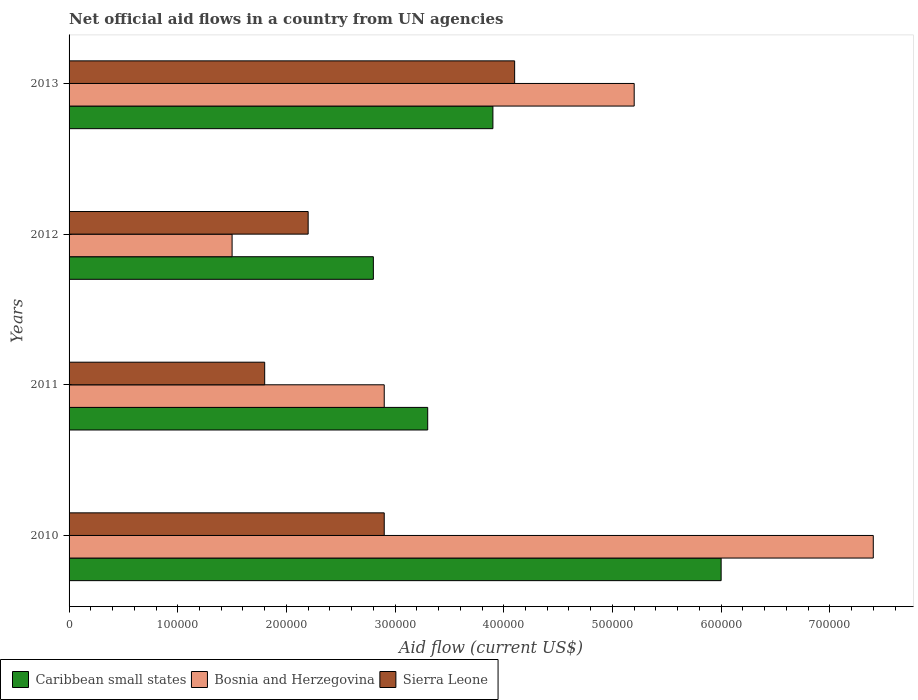How many groups of bars are there?
Offer a very short reply. 4. Are the number of bars per tick equal to the number of legend labels?
Keep it short and to the point. Yes. Are the number of bars on each tick of the Y-axis equal?
Keep it short and to the point. Yes. How many bars are there on the 4th tick from the bottom?
Ensure brevity in your answer.  3. What is the net official aid flow in Caribbean small states in 2010?
Your answer should be compact. 6.00e+05. Across all years, what is the maximum net official aid flow in Caribbean small states?
Provide a short and direct response. 6.00e+05. Across all years, what is the minimum net official aid flow in Bosnia and Herzegovina?
Keep it short and to the point. 1.50e+05. In which year was the net official aid flow in Bosnia and Herzegovina maximum?
Offer a terse response. 2010. In which year was the net official aid flow in Sierra Leone minimum?
Make the answer very short. 2011. What is the total net official aid flow in Bosnia and Herzegovina in the graph?
Your answer should be very brief. 1.70e+06. What is the difference between the net official aid flow in Sierra Leone in 2010 and that in 2013?
Ensure brevity in your answer.  -1.20e+05. What is the difference between the net official aid flow in Bosnia and Herzegovina in 2013 and the net official aid flow in Sierra Leone in 2012?
Ensure brevity in your answer.  3.00e+05. What is the average net official aid flow in Sierra Leone per year?
Offer a very short reply. 2.75e+05. In the year 2010, what is the difference between the net official aid flow in Caribbean small states and net official aid flow in Bosnia and Herzegovina?
Your response must be concise. -1.40e+05. What is the ratio of the net official aid flow in Bosnia and Herzegovina in 2011 to that in 2012?
Your answer should be very brief. 1.93. What is the difference between the highest and the lowest net official aid flow in Bosnia and Herzegovina?
Your response must be concise. 5.90e+05. In how many years, is the net official aid flow in Caribbean small states greater than the average net official aid flow in Caribbean small states taken over all years?
Give a very brief answer. 1. What does the 2nd bar from the top in 2010 represents?
Your response must be concise. Bosnia and Herzegovina. What does the 3rd bar from the bottom in 2012 represents?
Offer a very short reply. Sierra Leone. How many bars are there?
Ensure brevity in your answer.  12. What is the difference between two consecutive major ticks on the X-axis?
Provide a short and direct response. 1.00e+05. Where does the legend appear in the graph?
Provide a succinct answer. Bottom left. How are the legend labels stacked?
Your answer should be compact. Horizontal. What is the title of the graph?
Keep it short and to the point. Net official aid flows in a country from UN agencies. What is the Aid flow (current US$) in Bosnia and Herzegovina in 2010?
Offer a terse response. 7.40e+05. What is the Aid flow (current US$) of Caribbean small states in 2011?
Give a very brief answer. 3.30e+05. What is the Aid flow (current US$) of Caribbean small states in 2012?
Make the answer very short. 2.80e+05. What is the Aid flow (current US$) of Bosnia and Herzegovina in 2012?
Ensure brevity in your answer.  1.50e+05. What is the Aid flow (current US$) in Bosnia and Herzegovina in 2013?
Your answer should be compact. 5.20e+05. Across all years, what is the maximum Aid flow (current US$) in Caribbean small states?
Ensure brevity in your answer.  6.00e+05. Across all years, what is the maximum Aid flow (current US$) in Bosnia and Herzegovina?
Offer a terse response. 7.40e+05. Across all years, what is the minimum Aid flow (current US$) of Sierra Leone?
Provide a succinct answer. 1.80e+05. What is the total Aid flow (current US$) of Caribbean small states in the graph?
Give a very brief answer. 1.60e+06. What is the total Aid flow (current US$) in Bosnia and Herzegovina in the graph?
Ensure brevity in your answer.  1.70e+06. What is the total Aid flow (current US$) in Sierra Leone in the graph?
Offer a very short reply. 1.10e+06. What is the difference between the Aid flow (current US$) in Caribbean small states in 2010 and that in 2011?
Give a very brief answer. 2.70e+05. What is the difference between the Aid flow (current US$) in Caribbean small states in 2010 and that in 2012?
Your response must be concise. 3.20e+05. What is the difference between the Aid flow (current US$) in Bosnia and Herzegovina in 2010 and that in 2012?
Ensure brevity in your answer.  5.90e+05. What is the difference between the Aid flow (current US$) in Sierra Leone in 2010 and that in 2012?
Your answer should be compact. 7.00e+04. What is the difference between the Aid flow (current US$) of Bosnia and Herzegovina in 2010 and that in 2013?
Provide a short and direct response. 2.20e+05. What is the difference between the Aid flow (current US$) in Sierra Leone in 2010 and that in 2013?
Keep it short and to the point. -1.20e+05. What is the difference between the Aid flow (current US$) of Caribbean small states in 2011 and that in 2012?
Your answer should be very brief. 5.00e+04. What is the difference between the Aid flow (current US$) in Bosnia and Herzegovina in 2011 and that in 2012?
Provide a succinct answer. 1.40e+05. What is the difference between the Aid flow (current US$) in Sierra Leone in 2011 and that in 2012?
Make the answer very short. -4.00e+04. What is the difference between the Aid flow (current US$) of Caribbean small states in 2011 and that in 2013?
Give a very brief answer. -6.00e+04. What is the difference between the Aid flow (current US$) in Bosnia and Herzegovina in 2011 and that in 2013?
Keep it short and to the point. -2.30e+05. What is the difference between the Aid flow (current US$) of Bosnia and Herzegovina in 2012 and that in 2013?
Offer a terse response. -3.70e+05. What is the difference between the Aid flow (current US$) in Caribbean small states in 2010 and the Aid flow (current US$) in Bosnia and Herzegovina in 2011?
Ensure brevity in your answer.  3.10e+05. What is the difference between the Aid flow (current US$) in Bosnia and Herzegovina in 2010 and the Aid flow (current US$) in Sierra Leone in 2011?
Keep it short and to the point. 5.60e+05. What is the difference between the Aid flow (current US$) of Caribbean small states in 2010 and the Aid flow (current US$) of Bosnia and Herzegovina in 2012?
Your answer should be very brief. 4.50e+05. What is the difference between the Aid flow (current US$) in Bosnia and Herzegovina in 2010 and the Aid flow (current US$) in Sierra Leone in 2012?
Keep it short and to the point. 5.20e+05. What is the difference between the Aid flow (current US$) in Caribbean small states in 2010 and the Aid flow (current US$) in Sierra Leone in 2013?
Provide a succinct answer. 1.90e+05. What is the difference between the Aid flow (current US$) of Bosnia and Herzegovina in 2011 and the Aid flow (current US$) of Sierra Leone in 2012?
Keep it short and to the point. 7.00e+04. What is the difference between the Aid flow (current US$) of Caribbean small states in 2011 and the Aid flow (current US$) of Sierra Leone in 2013?
Your answer should be compact. -8.00e+04. What is the difference between the Aid flow (current US$) of Caribbean small states in 2012 and the Aid flow (current US$) of Bosnia and Herzegovina in 2013?
Keep it short and to the point. -2.40e+05. What is the average Aid flow (current US$) in Bosnia and Herzegovina per year?
Ensure brevity in your answer.  4.25e+05. What is the average Aid flow (current US$) in Sierra Leone per year?
Offer a terse response. 2.75e+05. In the year 2010, what is the difference between the Aid flow (current US$) of Caribbean small states and Aid flow (current US$) of Bosnia and Herzegovina?
Ensure brevity in your answer.  -1.40e+05. In the year 2010, what is the difference between the Aid flow (current US$) of Caribbean small states and Aid flow (current US$) of Sierra Leone?
Keep it short and to the point. 3.10e+05. In the year 2010, what is the difference between the Aid flow (current US$) in Bosnia and Herzegovina and Aid flow (current US$) in Sierra Leone?
Make the answer very short. 4.50e+05. In the year 2011, what is the difference between the Aid flow (current US$) of Caribbean small states and Aid flow (current US$) of Sierra Leone?
Offer a very short reply. 1.50e+05. In the year 2011, what is the difference between the Aid flow (current US$) in Bosnia and Herzegovina and Aid flow (current US$) in Sierra Leone?
Offer a very short reply. 1.10e+05. In the year 2012, what is the difference between the Aid flow (current US$) of Caribbean small states and Aid flow (current US$) of Sierra Leone?
Offer a very short reply. 6.00e+04. In the year 2013, what is the difference between the Aid flow (current US$) of Caribbean small states and Aid flow (current US$) of Bosnia and Herzegovina?
Ensure brevity in your answer.  -1.30e+05. In the year 2013, what is the difference between the Aid flow (current US$) of Bosnia and Herzegovina and Aid flow (current US$) of Sierra Leone?
Your answer should be compact. 1.10e+05. What is the ratio of the Aid flow (current US$) in Caribbean small states in 2010 to that in 2011?
Your response must be concise. 1.82. What is the ratio of the Aid flow (current US$) in Bosnia and Herzegovina in 2010 to that in 2011?
Ensure brevity in your answer.  2.55. What is the ratio of the Aid flow (current US$) of Sierra Leone in 2010 to that in 2011?
Make the answer very short. 1.61. What is the ratio of the Aid flow (current US$) in Caribbean small states in 2010 to that in 2012?
Provide a succinct answer. 2.14. What is the ratio of the Aid flow (current US$) in Bosnia and Herzegovina in 2010 to that in 2012?
Make the answer very short. 4.93. What is the ratio of the Aid flow (current US$) of Sierra Leone in 2010 to that in 2012?
Keep it short and to the point. 1.32. What is the ratio of the Aid flow (current US$) of Caribbean small states in 2010 to that in 2013?
Provide a succinct answer. 1.54. What is the ratio of the Aid flow (current US$) in Bosnia and Herzegovina in 2010 to that in 2013?
Make the answer very short. 1.42. What is the ratio of the Aid flow (current US$) in Sierra Leone in 2010 to that in 2013?
Offer a terse response. 0.71. What is the ratio of the Aid flow (current US$) in Caribbean small states in 2011 to that in 2012?
Make the answer very short. 1.18. What is the ratio of the Aid flow (current US$) of Bosnia and Herzegovina in 2011 to that in 2012?
Your answer should be very brief. 1.93. What is the ratio of the Aid flow (current US$) of Sierra Leone in 2011 to that in 2012?
Provide a short and direct response. 0.82. What is the ratio of the Aid flow (current US$) in Caribbean small states in 2011 to that in 2013?
Your answer should be very brief. 0.85. What is the ratio of the Aid flow (current US$) in Bosnia and Herzegovina in 2011 to that in 2013?
Your response must be concise. 0.56. What is the ratio of the Aid flow (current US$) in Sierra Leone in 2011 to that in 2013?
Your answer should be compact. 0.44. What is the ratio of the Aid flow (current US$) in Caribbean small states in 2012 to that in 2013?
Your answer should be compact. 0.72. What is the ratio of the Aid flow (current US$) in Bosnia and Herzegovina in 2012 to that in 2013?
Keep it short and to the point. 0.29. What is the ratio of the Aid flow (current US$) of Sierra Leone in 2012 to that in 2013?
Your answer should be compact. 0.54. What is the difference between the highest and the second highest Aid flow (current US$) in Bosnia and Herzegovina?
Your answer should be very brief. 2.20e+05. What is the difference between the highest and the second highest Aid flow (current US$) in Sierra Leone?
Your answer should be compact. 1.20e+05. What is the difference between the highest and the lowest Aid flow (current US$) of Caribbean small states?
Your answer should be compact. 3.20e+05. What is the difference between the highest and the lowest Aid flow (current US$) of Bosnia and Herzegovina?
Give a very brief answer. 5.90e+05. What is the difference between the highest and the lowest Aid flow (current US$) in Sierra Leone?
Give a very brief answer. 2.30e+05. 